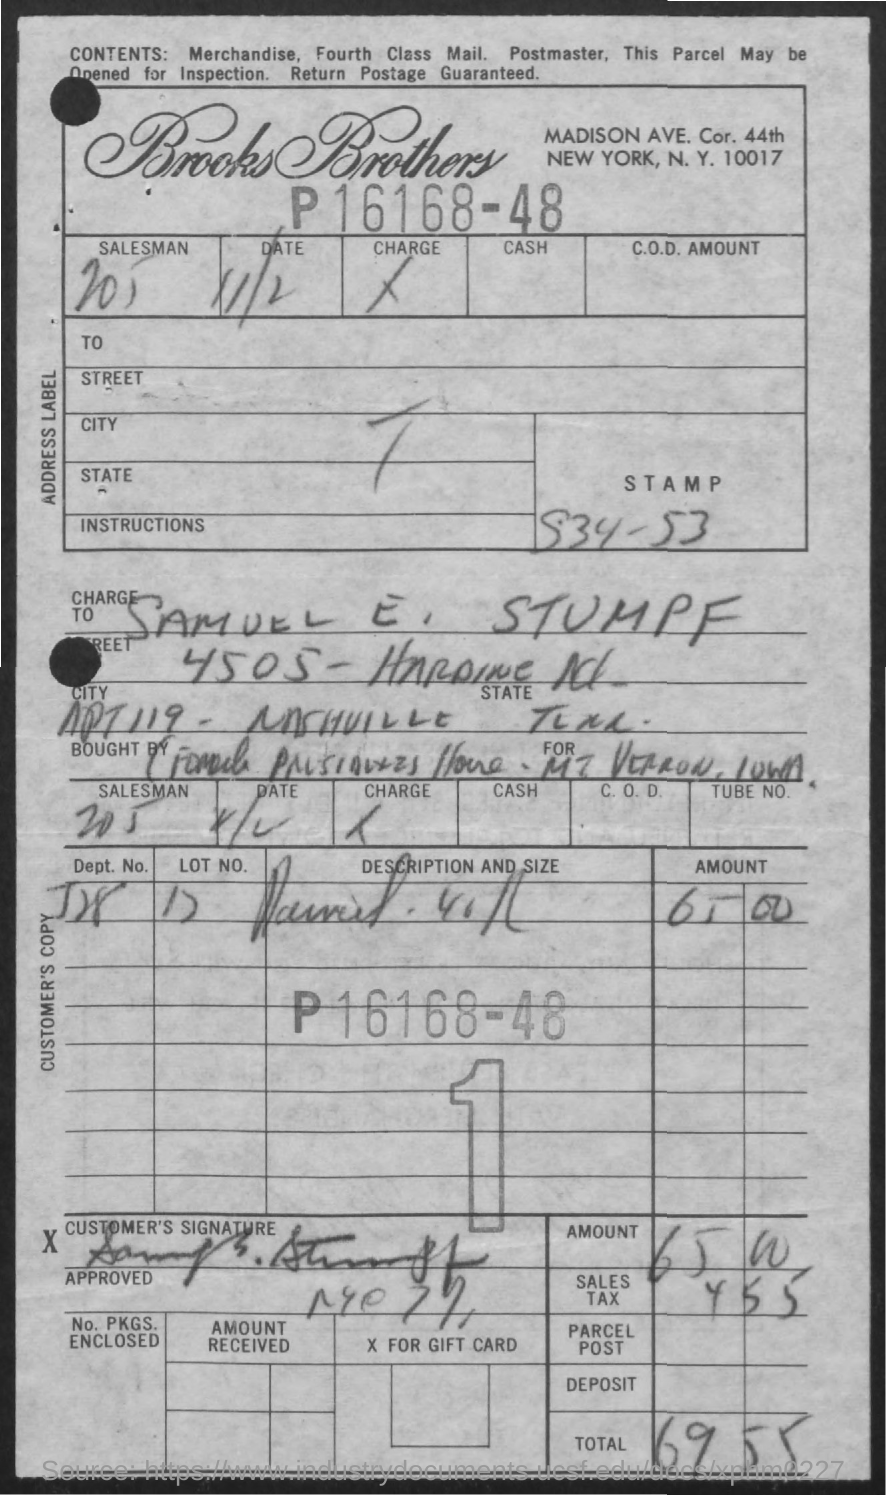Indicate a few pertinent items in this graphic. The total amount is 69 plus 55, which equals 124. The signature present in the document is that of Samuel E. Stumpf. The date mentioned in the document is 11/2. The lot number is 17... 